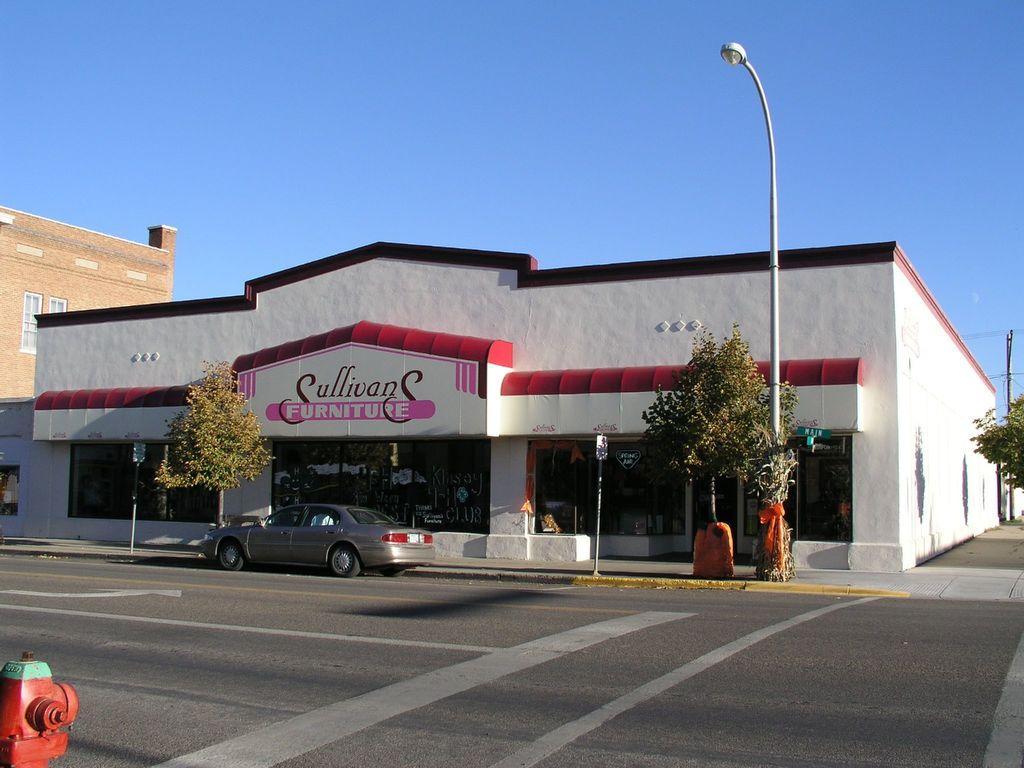Please provide a concise description of this image. In this image we can see the store, glass doors, beside we can see the building and window, we can see the vehicle on the road, there are few trees, street lights, in the bottom left corner we can see an object. 